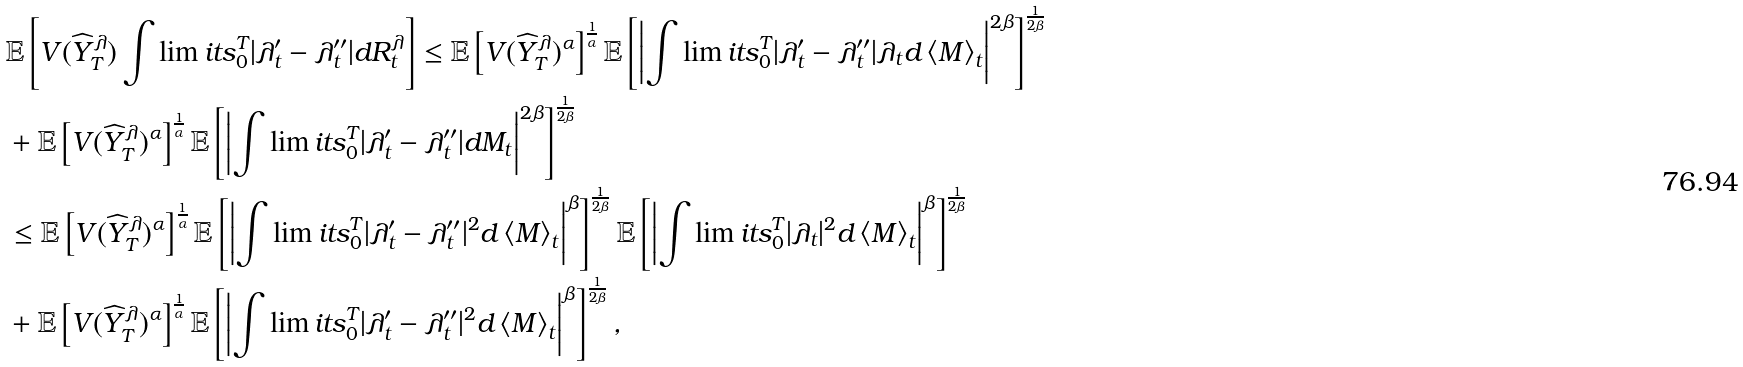Convert formula to latex. <formula><loc_0><loc_0><loc_500><loc_500>& \mathbb { E } \left [ V ( \widehat { Y } ^ { \lambda } _ { T } ) \int \lim i t s _ { 0 } ^ { T } { | \lambda _ { t } ^ { \prime } - \lambda _ { t } ^ { \prime \prime } | d R ^ { \lambda } _ { t } } \right ] \leq \mathbb { E } \left [ V ( \widehat { Y } ^ { \lambda } _ { T } ) ^ { \alpha } \right ] ^ { \frac { 1 } { \alpha } } \mathbb { E } \left [ \left | \int \lim i t s _ { 0 } ^ { T } { | \lambda _ { t } ^ { \prime } - \lambda _ { t } ^ { \prime \prime } | \lambda _ { t } d \left \langle M \right \rangle _ { t } } \right | ^ { 2 \beta } \right ] ^ { \frac { 1 } { 2 \beta } } \\ & + \mathbb { E } \left [ V ( \widehat { Y } ^ { \lambda } _ { T } ) ^ { \alpha } \right ] ^ { \frac { 1 } { \alpha } } \mathbb { E } \left [ \left | \int \lim i t s _ { 0 } ^ { T } { | \lambda _ { t } ^ { \prime } - \lambda _ { t } ^ { \prime \prime } | d M _ { t } } \right | ^ { 2 \beta } \right ] ^ { \frac { 1 } { 2 \beta } } \\ & \leq \mathbb { E } \left [ V ( \widehat { Y } ^ { \lambda } _ { T } ) ^ { \alpha } \right ] ^ { \frac { 1 } { \alpha } } \mathbb { E } \left [ \left | \int \lim i t s _ { 0 } ^ { T } { | \lambda _ { t } ^ { \prime } - \lambda _ { t } ^ { \prime \prime } | ^ { 2 } d \left \langle M \right \rangle _ { t } } \right | ^ { \beta } \right ] ^ { \frac { 1 } { 2 \beta } } \mathbb { E } \left [ \left | \int \lim i t s _ { 0 } ^ { T } { | \lambda _ { t } | ^ { 2 } d \left \langle M \right \rangle _ { t } } \right | ^ { \beta } \right ] ^ { \frac { 1 } { 2 \beta } } \\ & + \mathbb { E } \left [ V ( \widehat { Y } ^ { \lambda } _ { T } ) ^ { \alpha } \right ] ^ { \frac { 1 } { \alpha } } \mathbb { E } \left [ \left | \int \lim i t s _ { 0 } ^ { T } { | \lambda _ { t } ^ { \prime } - \lambda _ { t } ^ { \prime \prime } | ^ { 2 } d \left \langle M \right \rangle _ { t } } \right | ^ { \beta } \right ] ^ { \frac { 1 } { 2 \beta } } ,</formula> 